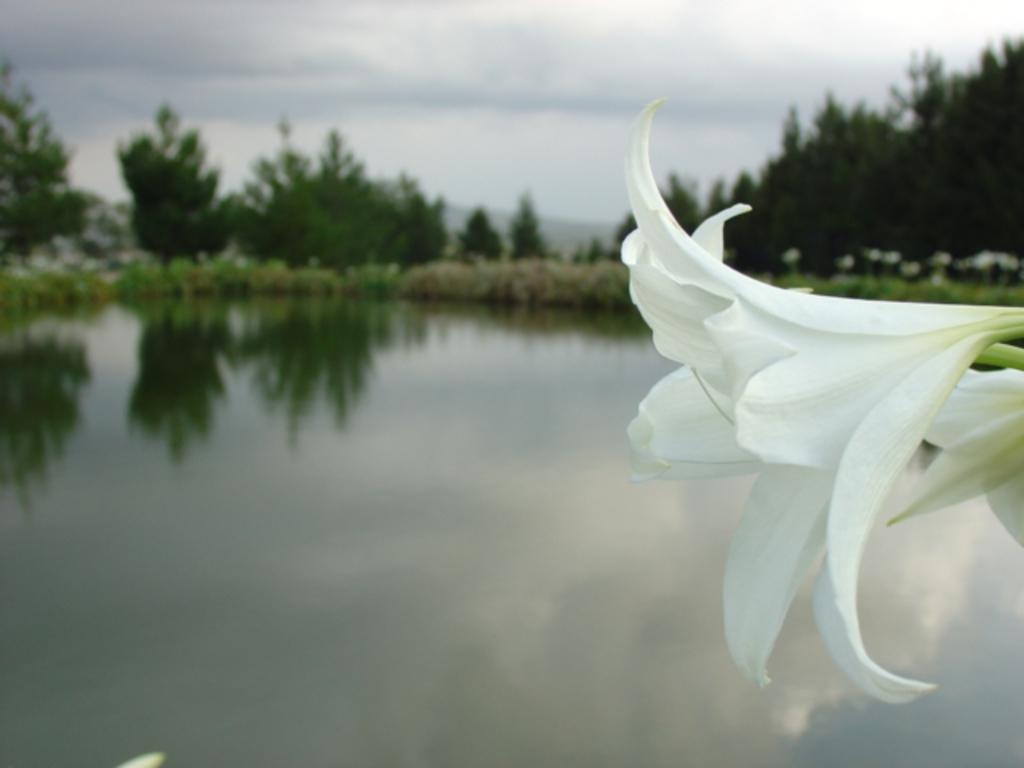What type of flora can be seen in the image? There are flowers in the image. What natural feature is visible in the background? There is a water body visible in the background. What other vegetation can be seen in the background? There is a group of plants and trees present in the background. What geographical feature is visible in the background? The hills are visible in the background. How would you describe the sky in the image? The sky is cloudy in the image. What type of noise can be heard coming from the lunchroom in the image? There is no lunchroom present in the image, so it's not possible to determine what noise might be heard. How many cattle are visible in the image? There are no cattle present in the image. 